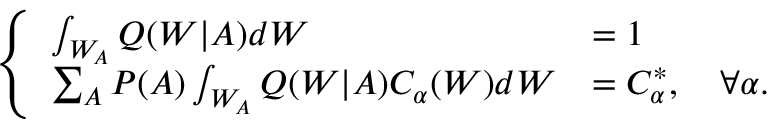<formula> <loc_0><loc_0><loc_500><loc_500>\left \{ \begin{array} { l l } { \int _ { W _ { A } } Q ( W | A ) d W } & { = 1 } \\ { \sum _ { A } P ( A ) \int _ { W _ { A } } Q ( W | A ) C _ { \alpha } ( W ) d W } & { = C _ { \alpha } ^ { * } , \quad \forall \alpha . } \end{array}</formula> 